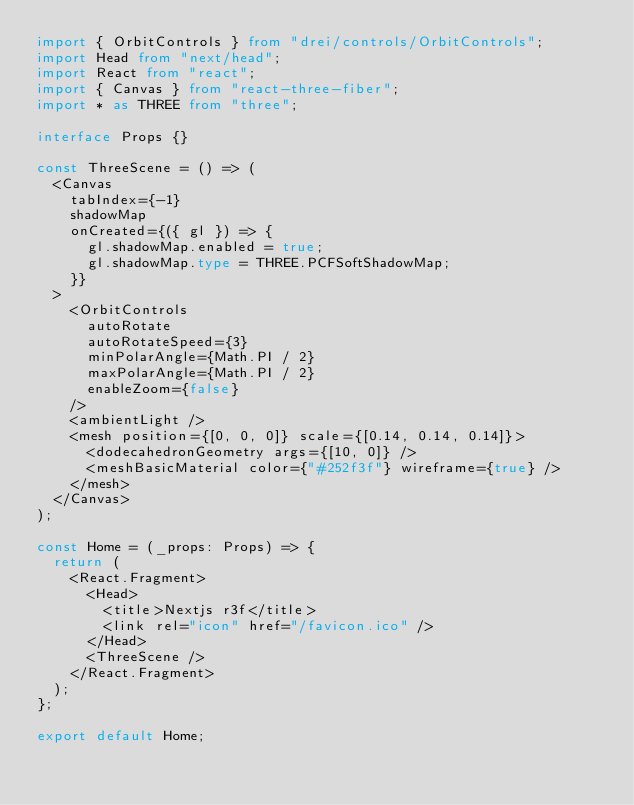Convert code to text. <code><loc_0><loc_0><loc_500><loc_500><_TypeScript_>import { OrbitControls } from "drei/controls/OrbitControls";
import Head from "next/head";
import React from "react";
import { Canvas } from "react-three-fiber";
import * as THREE from "three";

interface Props {}

const ThreeScene = () => (
  <Canvas
    tabIndex={-1}
    shadowMap
    onCreated={({ gl }) => {
      gl.shadowMap.enabled = true;
      gl.shadowMap.type = THREE.PCFSoftShadowMap;
    }}
  >
    <OrbitControls
      autoRotate
      autoRotateSpeed={3}
      minPolarAngle={Math.PI / 2}
      maxPolarAngle={Math.PI / 2}
      enableZoom={false}
    />
    <ambientLight />
    <mesh position={[0, 0, 0]} scale={[0.14, 0.14, 0.14]}>
      <dodecahedronGeometry args={[10, 0]} />
      <meshBasicMaterial color={"#252f3f"} wireframe={true} />
    </mesh>
  </Canvas>
);

const Home = (_props: Props) => {
  return (
    <React.Fragment>
      <Head>
        <title>Nextjs r3f</title>
        <link rel="icon" href="/favicon.ico" />
      </Head>
      <ThreeScene />
    </React.Fragment>
  );
};

export default Home;
</code> 